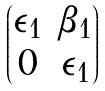Convert formula to latex. <formula><loc_0><loc_0><loc_500><loc_500>\begin{pmatrix} \epsilon _ { 1 } & \beta _ { 1 } \\ 0 & \epsilon _ { 1 } \end{pmatrix}</formula> 